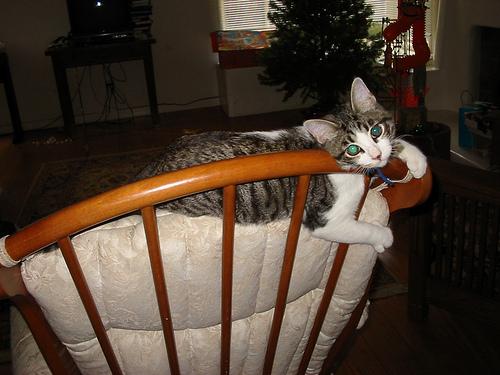What animal is in the picture?
Be succinct. Cat. Does this animal appear mesmerized?
Write a very short answer. Yes. What style of chair is the cat resting on?
Be succinct. Papasan. 